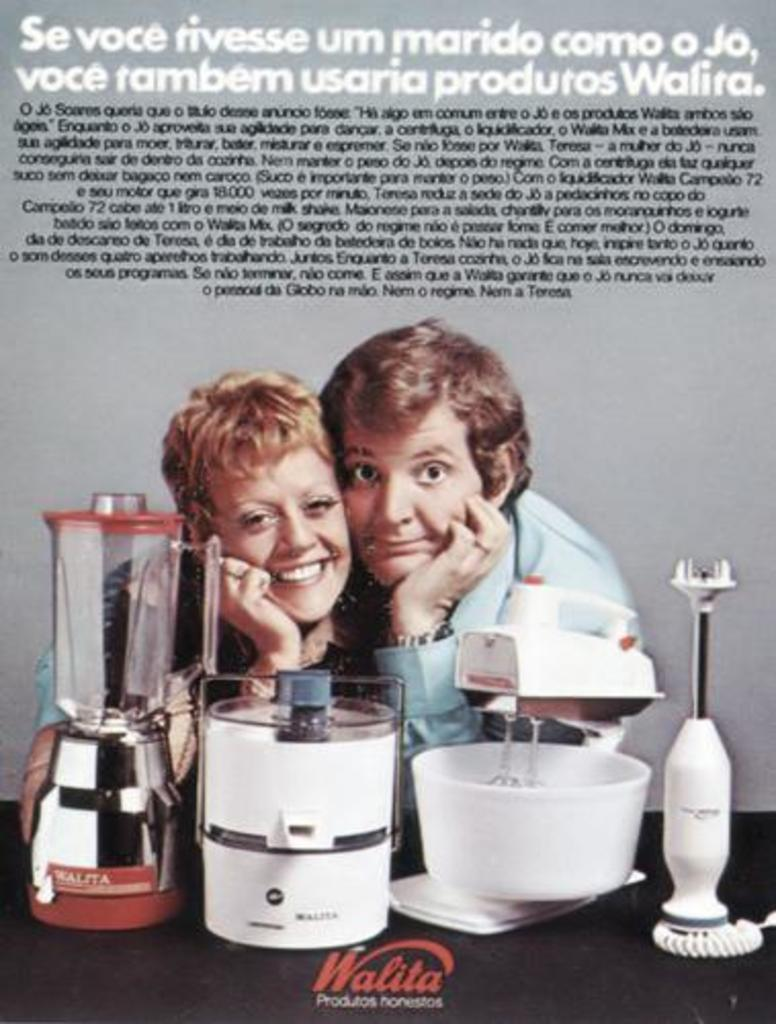<image>
Write a terse but informative summary of the picture. An advertisement for kitchen type appliances from Walita. 